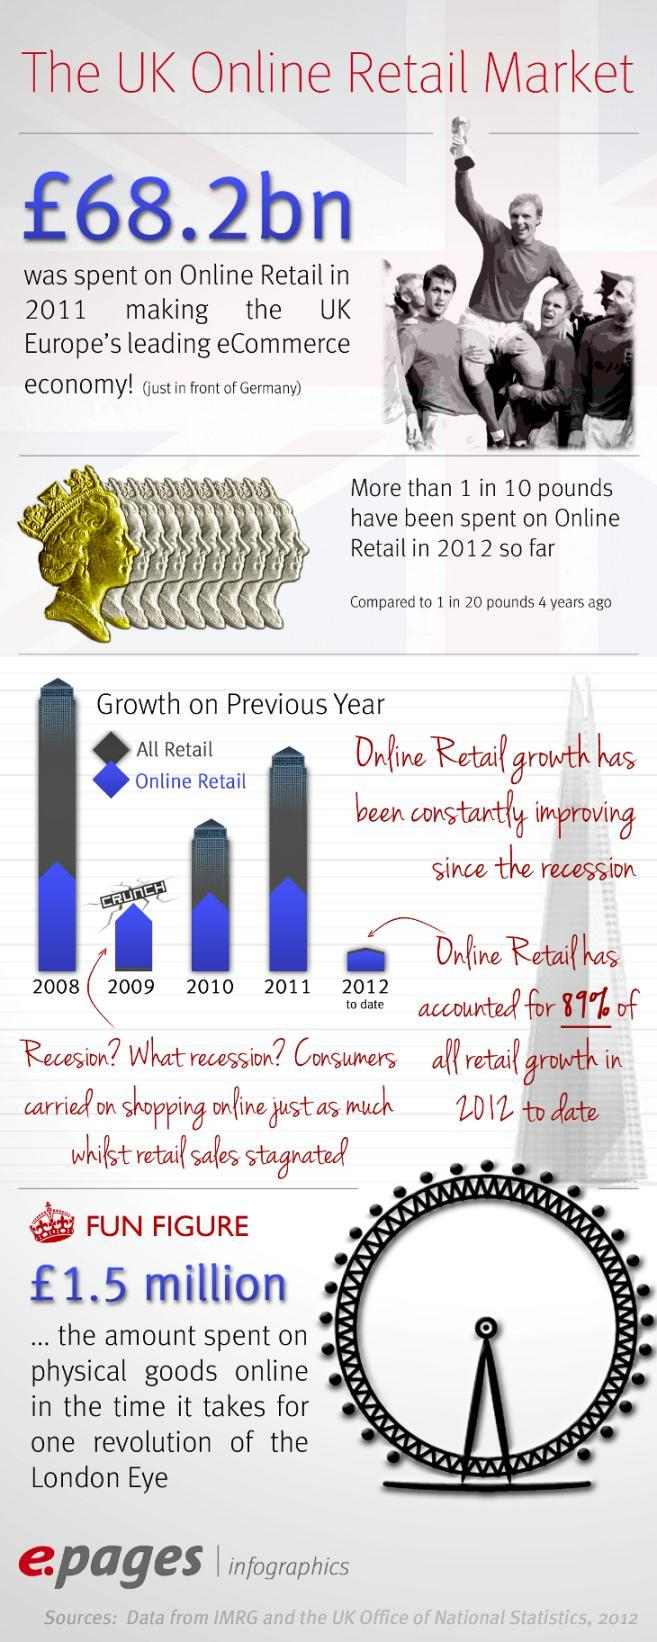Which country leads in second place in Europe's eCommerce economy in 2011?
Answer the question with a short phrase. Germany What is the increase in expenditure on online retail from 2008 to 2012? 5% 